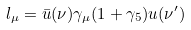Convert formula to latex. <formula><loc_0><loc_0><loc_500><loc_500>l _ { \mu } = \bar { u } ( \nu ) \gamma _ { \mu } ( 1 + \gamma _ { 5 } ) u ( \nu ^ { \prime } )</formula> 